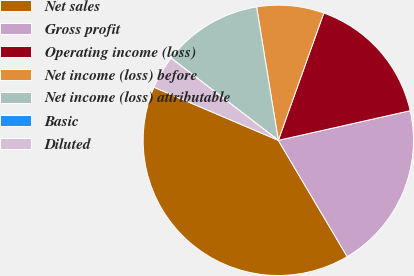<chart> <loc_0><loc_0><loc_500><loc_500><pie_chart><fcel>Net sales<fcel>Gross profit<fcel>Operating income (loss)<fcel>Net income (loss) before<fcel>Net income (loss) attributable<fcel>Basic<fcel>Diluted<nl><fcel>39.93%<fcel>20.01%<fcel>16.02%<fcel>8.03%<fcel>12.02%<fcel>0.0%<fcel>3.99%<nl></chart> 